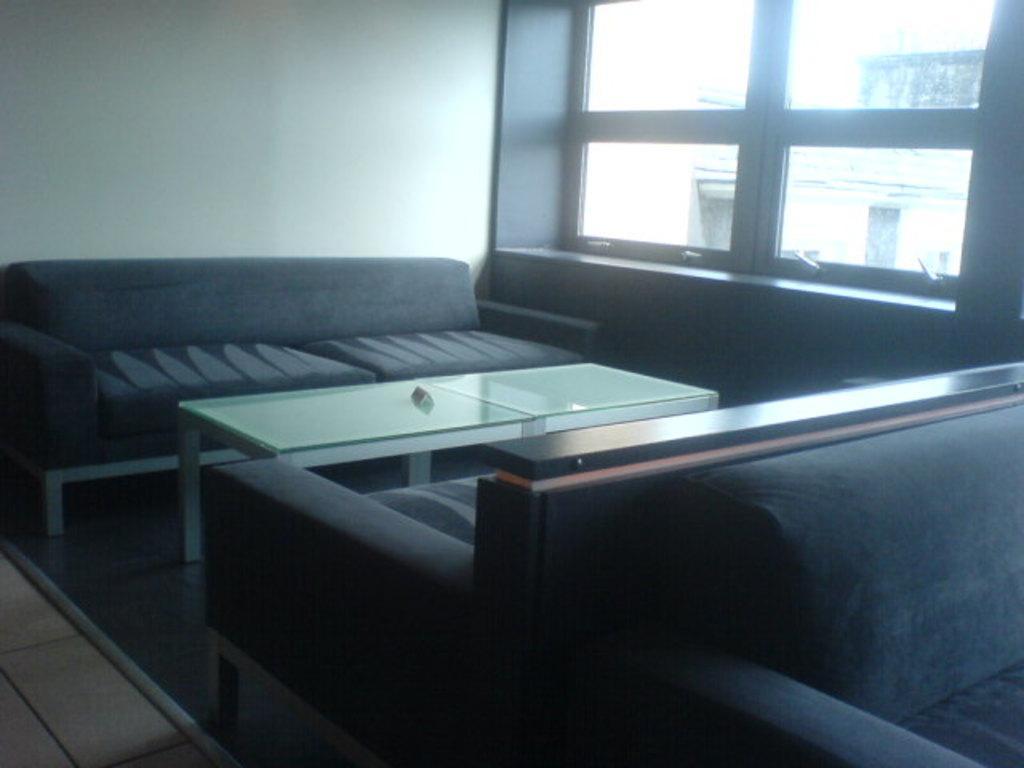How would you summarize this image in a sentence or two? This image is clicked inside a room In the middle there is a table and sofas. In the background there is a window, glass and wall. 